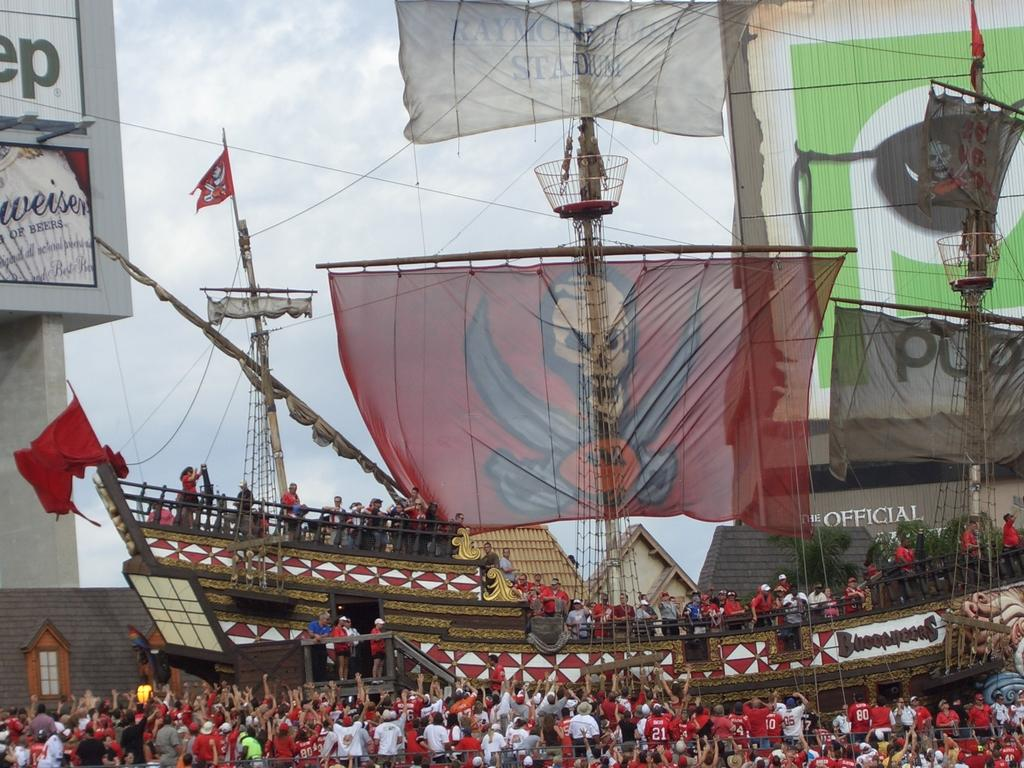What is the main subject of the image? There is a group of people in the image. What else can be seen in the image besides the people? There is a ship, flags, buildings, and clouds visible in the image. What type of vein is visible in the image? There is no vein present in the image. What loss is being experienced by the people in the image? There is no indication of loss in the image; it simply shows a group of people, a ship, flags, buildings, and clouds. 